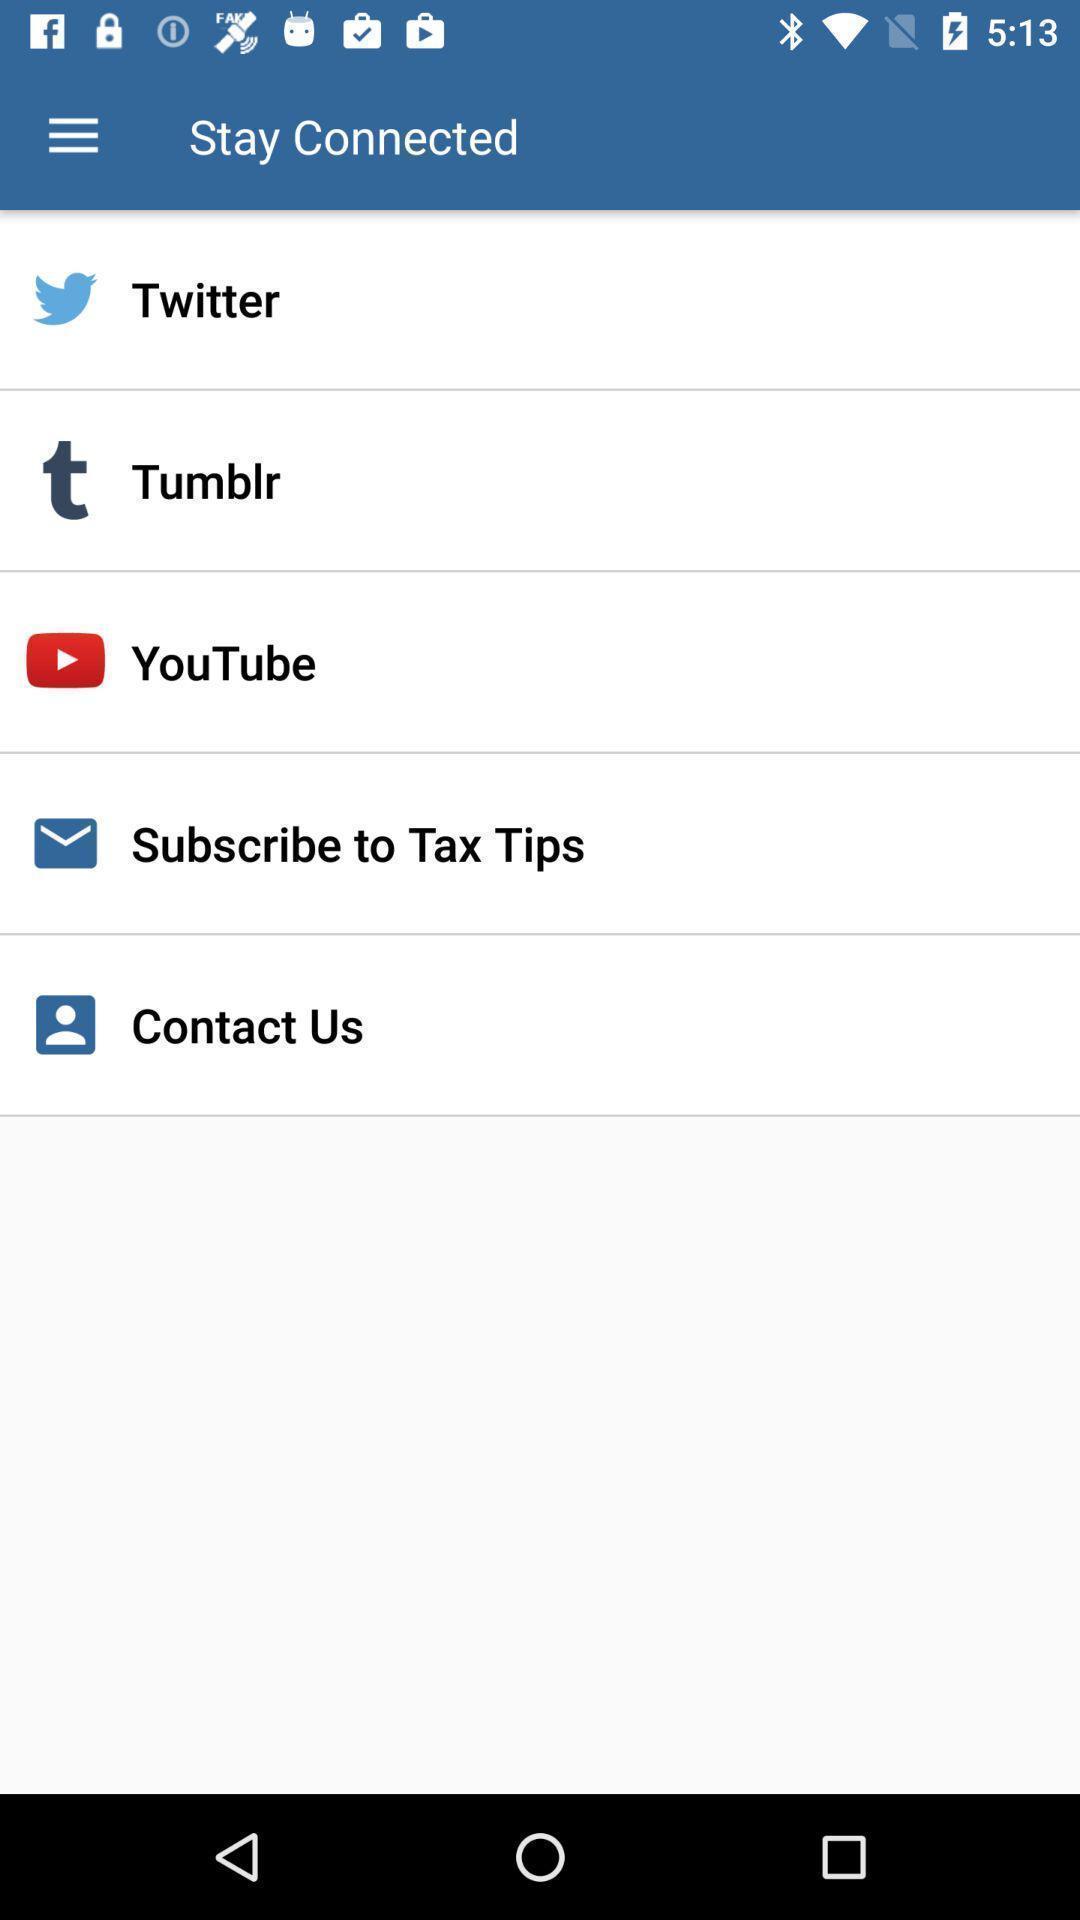Summarize the main components in this picture. Page displaying with list of different options to stay linked. 